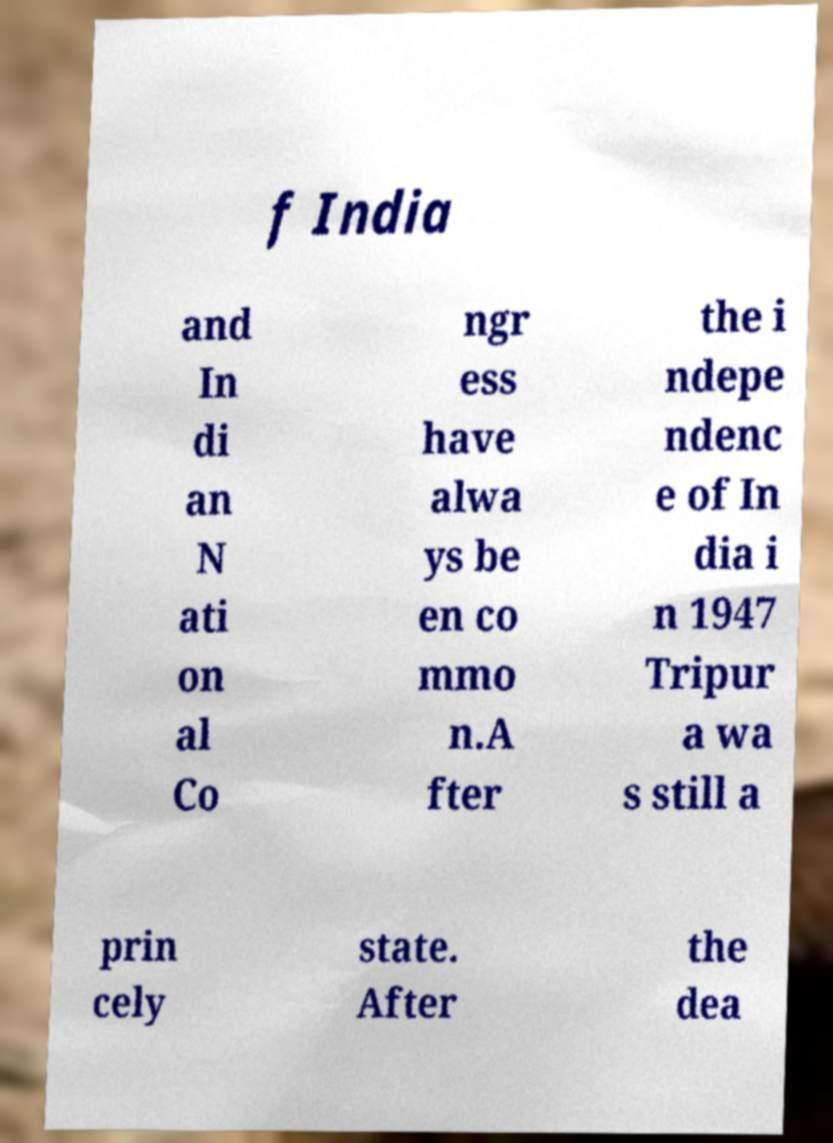Please read and relay the text visible in this image. What does it say? f India and In di an N ati on al Co ngr ess have alwa ys be en co mmo n.A fter the i ndepe ndenc e of In dia i n 1947 Tripur a wa s still a prin cely state. After the dea 